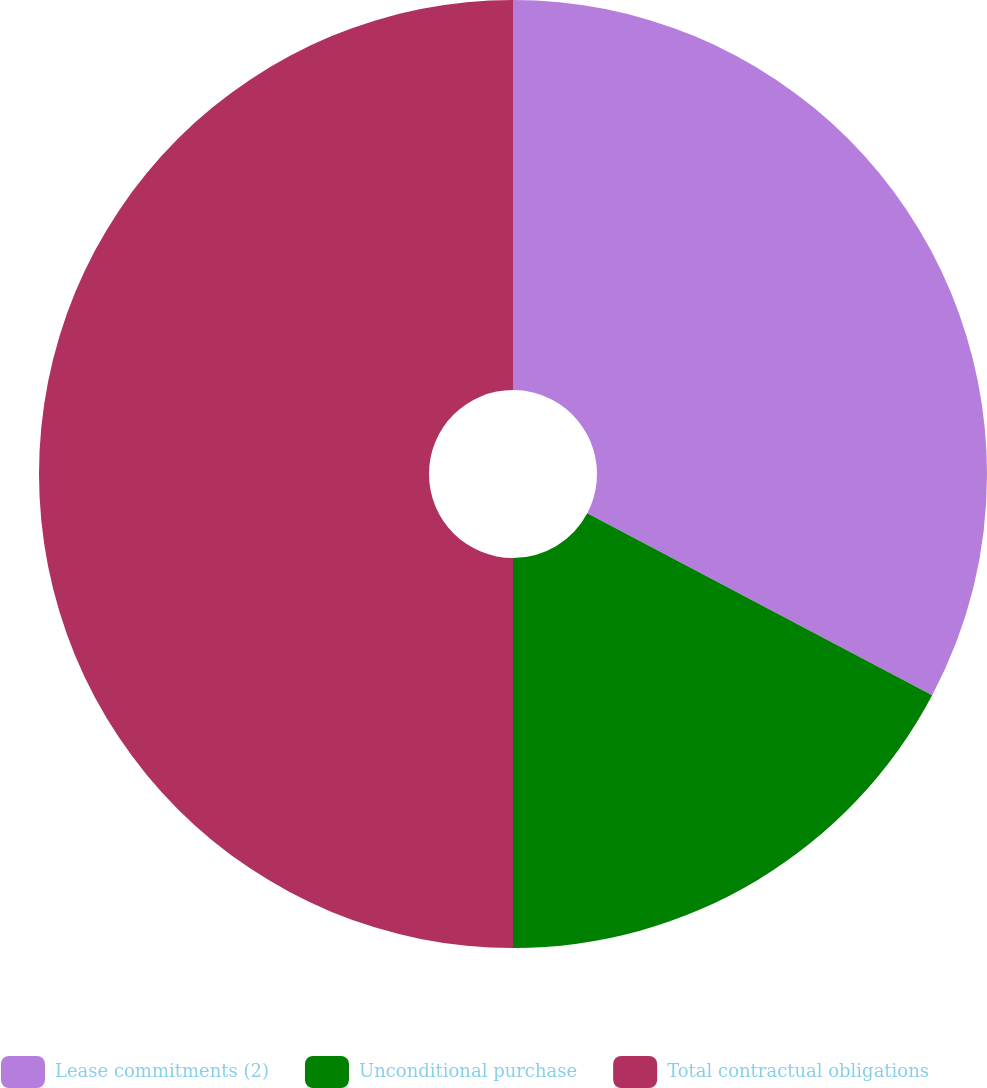Convert chart. <chart><loc_0><loc_0><loc_500><loc_500><pie_chart><fcel>Lease commitments (2)<fcel>Unconditional purchase<fcel>Total contractual obligations<nl><fcel>32.73%<fcel>17.27%<fcel>50.0%<nl></chart> 